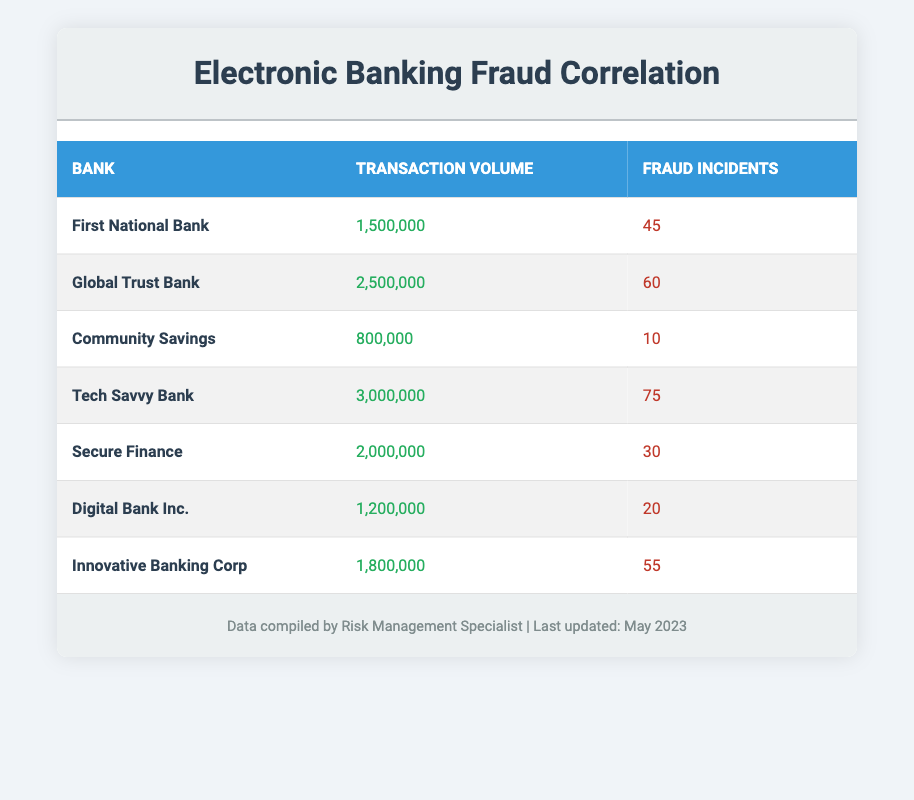What is the transaction volume of Tech Savvy Bank? Referring to the table, the transaction volume listed for Tech Savvy Bank is 3,000,000.
Answer: 3,000,000 Which bank has the highest number of fraud incidents? Looking at the table, Tech Savvy Bank has 75 fraud incidents, which is the highest among the listed banks.
Answer: Tech Savvy Bank What is the total transaction volume for all banks listed? To find the total transaction volume, add all the individual transaction volumes: 1,500,000 + 2,500,000 + 800,000 + 3,000,000 + 2,000,000 + 1,200,000 + 1,800,000 = 13,800,000.
Answer: 13,800,000 Does Innovative Banking Corp have more fraud incidents than Digital Bank Inc.? Checking the numbers, Innovative Banking Corp has 55 fraud incidents while Digital Bank Inc. has 20, therefore Innovative Banking Corp indeed has more fraud incidents.
Answer: Yes What is the average number of fraud incidents across all banks? First, sum the fraud incidents: 45 + 60 + 10 + 75 + 30 + 20 + 55 = 295. There are 7 banks, so the average can be calculated as 295 / 7 = 42.14, rounded to two decimal places.
Answer: 42.14 Which bank shows the lowest fraud incidents, and how many are there? Referring to the table, Community Savings has the lowest number of fraud incidents at 10.
Answer: Community Savings, 10 Is the fraud incident count proportional to the transaction volume in all cases? To determine this, compare the fraud incidents to transaction volumes for each bank. While some banks like Tech Savvy Bank have a high volume and incidents, others like Community Savings have low statistics. Thus, the relationship is not consistent across all banks.
Answer: No What is the difference in transaction volume between Global Trust Bank and Secure Finance? Global Trust Bank has a transaction volume of 2,500,000, while Secure Finance has 2,000,000. The difference is 2,500,000 - 2,000,000 = 500,000.
Answer: 500,000 